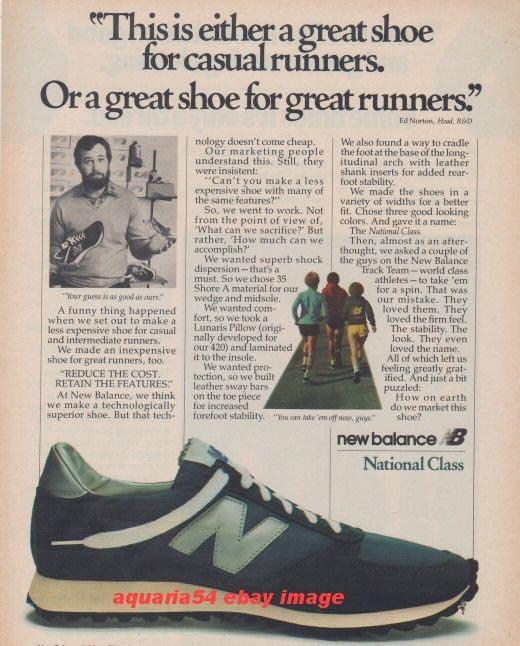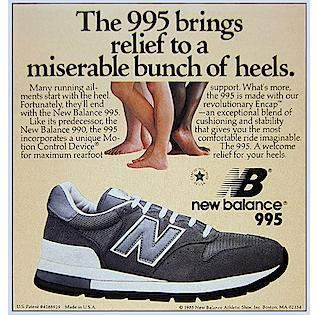The first image is the image on the left, the second image is the image on the right. Given the left and right images, does the statement "The shoes in each of the images are depicted in an advertisement." hold true? Answer yes or no. Yes. The first image is the image on the left, the second image is the image on the right. Given the left and right images, does the statement "Left and right images contain the same number of sneakers displayed in the same position, and no human legs are depicted anywhere in either image." hold true? Answer yes or no. No. 